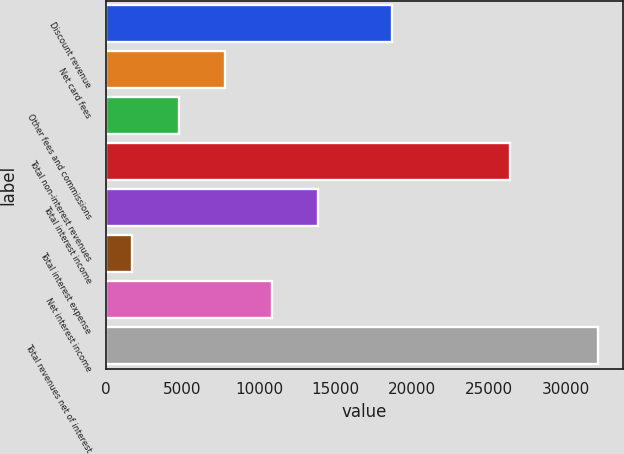<chart> <loc_0><loc_0><loc_500><loc_500><bar_chart><fcel>Discount revenue<fcel>Net card fees<fcel>Other fees and commissions<fcel>Total non-interest revenues<fcel>Total interest income<fcel>Total interest expense<fcel>Net interest income<fcel>Total revenues net of interest<nl><fcel>18680<fcel>7787<fcel>4745.5<fcel>26348<fcel>13870<fcel>1704<fcel>10828.5<fcel>32119<nl></chart> 